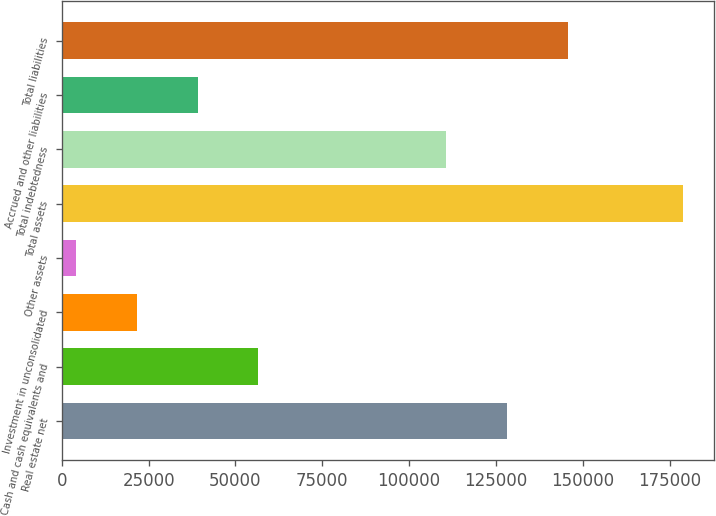Convert chart. <chart><loc_0><loc_0><loc_500><loc_500><bar_chart><fcel>Real estate net<fcel>Cash and cash equivalents and<fcel>Investment in unconsolidated<fcel>Other assets<fcel>Total assets<fcel>Total indebtedness<fcel>Accrued and other liabilities<fcel>Total liabilities<nl><fcel>128195<fcel>56537.6<fcel>21621.2<fcel>4163<fcel>178745<fcel>110737<fcel>39079.4<fcel>145653<nl></chart> 